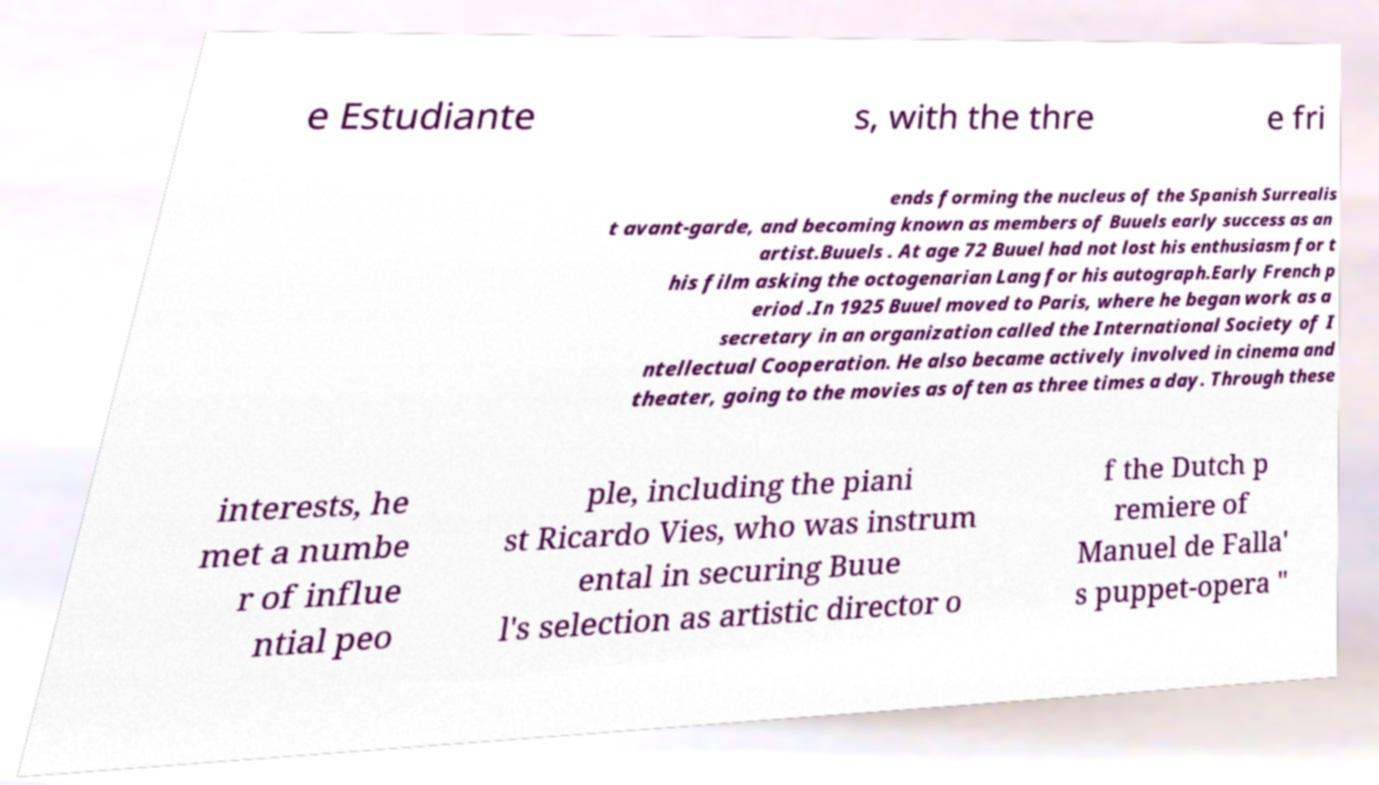Can you read and provide the text displayed in the image?This photo seems to have some interesting text. Can you extract and type it out for me? e Estudiante s, with the thre e fri ends forming the nucleus of the Spanish Surrealis t avant-garde, and becoming known as members of Buuels early success as an artist.Buuels . At age 72 Buuel had not lost his enthusiasm for t his film asking the octogenarian Lang for his autograph.Early French p eriod .In 1925 Buuel moved to Paris, where he began work as a secretary in an organization called the International Society of I ntellectual Cooperation. He also became actively involved in cinema and theater, going to the movies as often as three times a day. Through these interests, he met a numbe r of influe ntial peo ple, including the piani st Ricardo Vies, who was instrum ental in securing Buue l's selection as artistic director o f the Dutch p remiere of Manuel de Falla' s puppet-opera " 